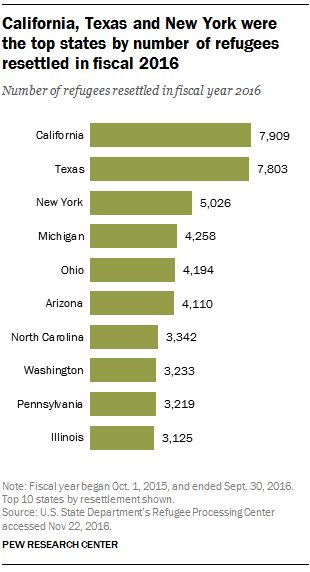Highlight a few significant elements in this photo. In the first two bars from the bottom of the stack, the average is greater than the smallest bar in the stack. In 2016, 7,803 refugees were resettled in Texas. 